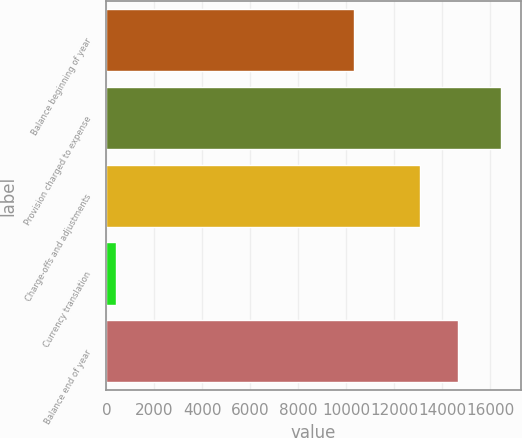<chart> <loc_0><loc_0><loc_500><loc_500><bar_chart><fcel>Balance beginning of year<fcel>Provision charged to expense<fcel>Charge-offs and adjustments<fcel>Currency translation<fcel>Balance end of year<nl><fcel>10322<fcel>16451<fcel>13072<fcel>415<fcel>14675.6<nl></chart> 